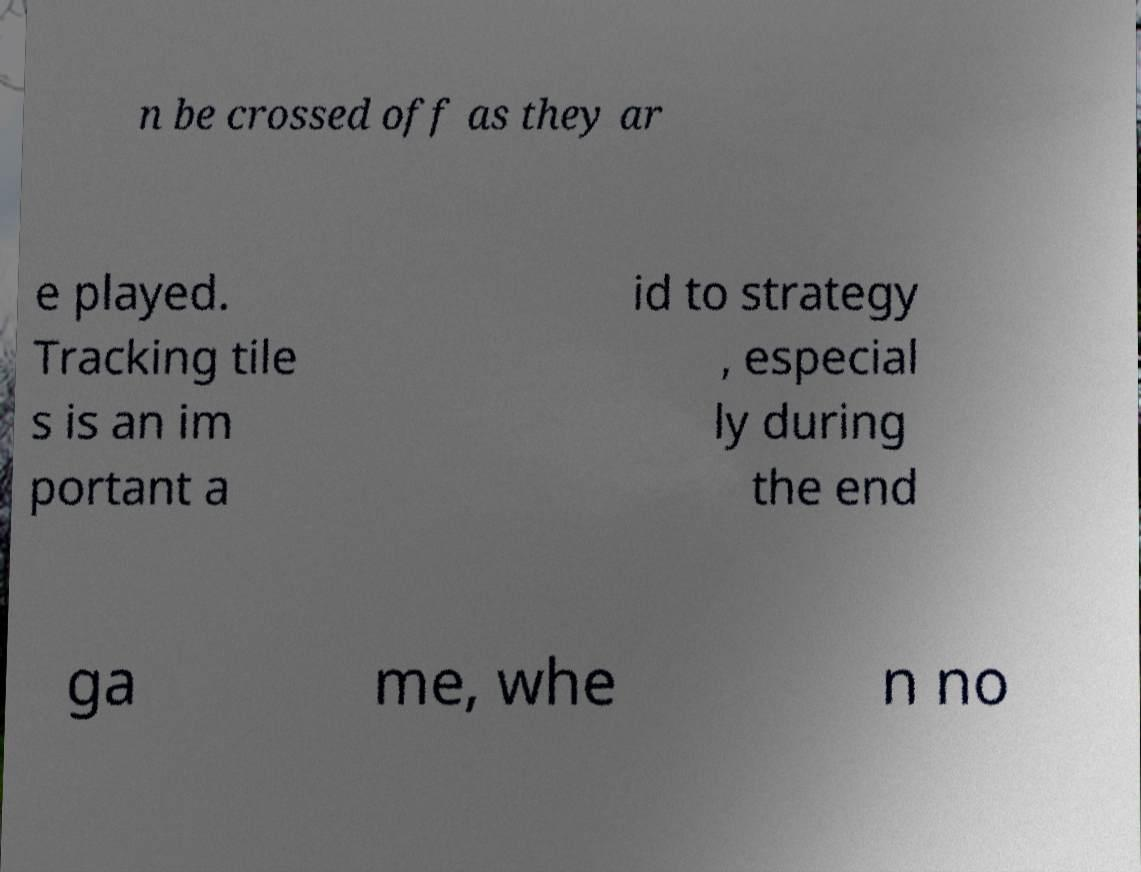Can you accurately transcribe the text from the provided image for me? n be crossed off as they ar e played. Tracking tile s is an im portant a id to strategy , especial ly during the end ga me, whe n no 